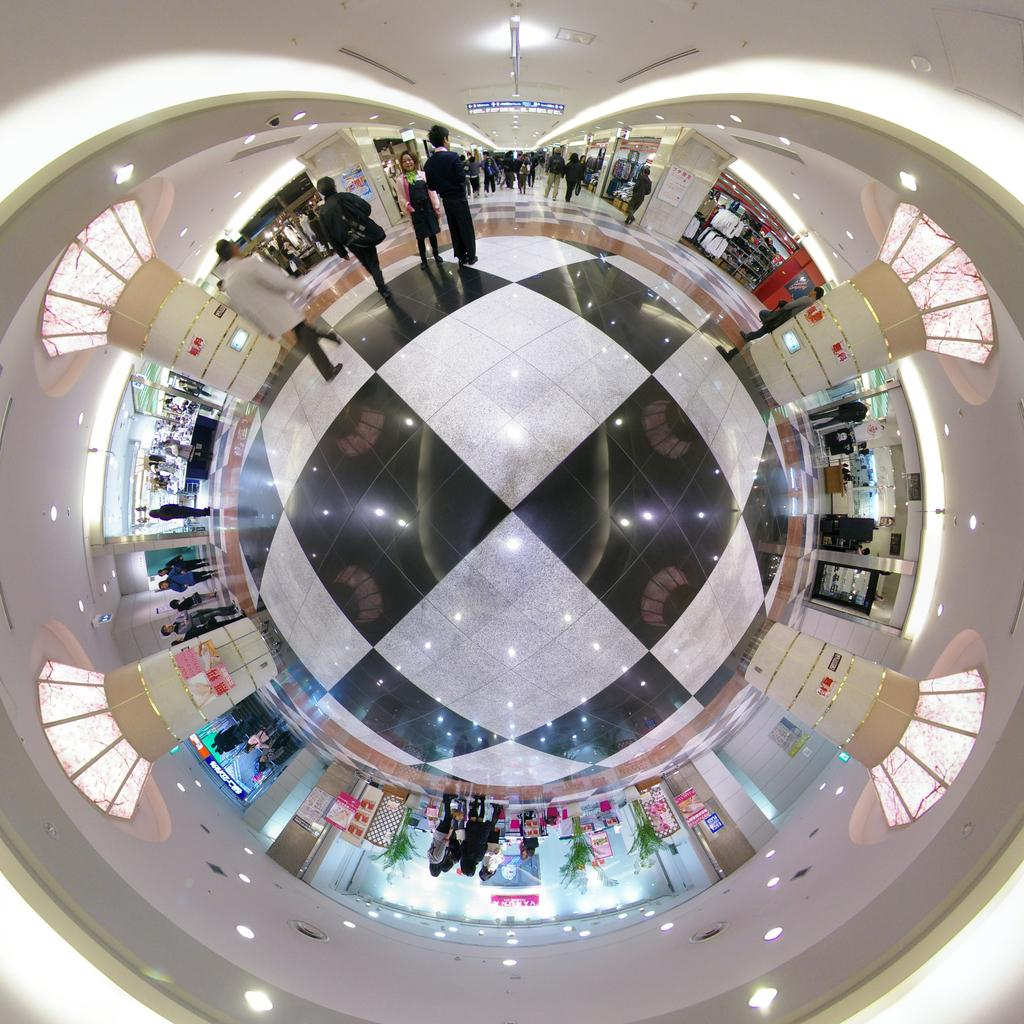What can be inferred about the image based on the provided fact? The image appears to be edited and checked. Where is the image set? The image is set in a shopping complex. How many people are visible in the image? There are many people in the image. What color are the walls in the image? The walls in the image are white. What type of lace can be seen on the mother's dress in the image? There is no mother or dress present in the image, so it is not possible to determine the type of lace on a dress. 